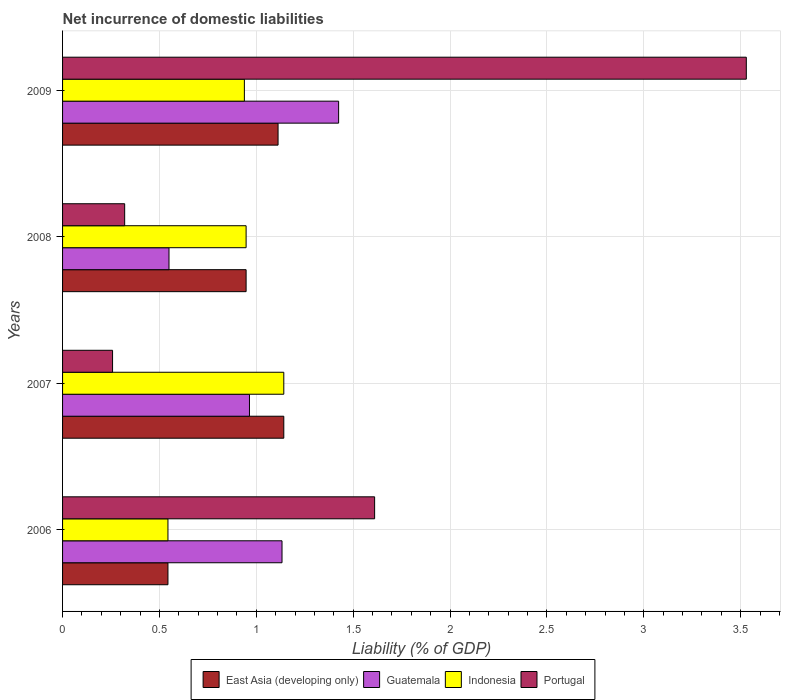Are the number of bars on each tick of the Y-axis equal?
Your answer should be compact. Yes. What is the label of the 1st group of bars from the top?
Your response must be concise. 2009. What is the net incurrence of domestic liabilities in Portugal in 2009?
Offer a very short reply. 3.53. Across all years, what is the maximum net incurrence of domestic liabilities in East Asia (developing only)?
Your answer should be compact. 1.14. Across all years, what is the minimum net incurrence of domestic liabilities in East Asia (developing only)?
Your response must be concise. 0.54. In which year was the net incurrence of domestic liabilities in Portugal minimum?
Give a very brief answer. 2007. What is the total net incurrence of domestic liabilities in Indonesia in the graph?
Make the answer very short. 3.57. What is the difference between the net incurrence of domestic liabilities in Indonesia in 2006 and that in 2008?
Ensure brevity in your answer.  -0.4. What is the difference between the net incurrence of domestic liabilities in Portugal in 2008 and the net incurrence of domestic liabilities in Guatemala in 2007?
Your answer should be very brief. -0.64. What is the average net incurrence of domestic liabilities in Guatemala per year?
Offer a very short reply. 1.02. In the year 2006, what is the difference between the net incurrence of domestic liabilities in East Asia (developing only) and net incurrence of domestic liabilities in Guatemala?
Provide a short and direct response. -0.59. What is the ratio of the net incurrence of domestic liabilities in East Asia (developing only) in 2006 to that in 2008?
Offer a terse response. 0.57. Is the net incurrence of domestic liabilities in Indonesia in 2008 less than that in 2009?
Your response must be concise. No. Is the difference between the net incurrence of domestic liabilities in East Asia (developing only) in 2008 and 2009 greater than the difference between the net incurrence of domestic liabilities in Guatemala in 2008 and 2009?
Offer a terse response. Yes. What is the difference between the highest and the second highest net incurrence of domestic liabilities in Guatemala?
Ensure brevity in your answer.  0.29. What is the difference between the highest and the lowest net incurrence of domestic liabilities in Indonesia?
Keep it short and to the point. 0.6. Is the sum of the net incurrence of domestic liabilities in Portugal in 2008 and 2009 greater than the maximum net incurrence of domestic liabilities in Indonesia across all years?
Give a very brief answer. Yes. What does the 3rd bar from the top in 2006 represents?
Give a very brief answer. Guatemala. What does the 2nd bar from the bottom in 2006 represents?
Provide a short and direct response. Guatemala. Is it the case that in every year, the sum of the net incurrence of domestic liabilities in East Asia (developing only) and net incurrence of domestic liabilities in Guatemala is greater than the net incurrence of domestic liabilities in Indonesia?
Give a very brief answer. Yes. How many bars are there?
Provide a succinct answer. 16. Are the values on the major ticks of X-axis written in scientific E-notation?
Your answer should be very brief. No. Does the graph contain any zero values?
Offer a very short reply. No. How are the legend labels stacked?
Ensure brevity in your answer.  Horizontal. What is the title of the graph?
Make the answer very short. Net incurrence of domestic liabilities. What is the label or title of the X-axis?
Ensure brevity in your answer.  Liability (% of GDP). What is the label or title of the Y-axis?
Make the answer very short. Years. What is the Liability (% of GDP) of East Asia (developing only) in 2006?
Give a very brief answer. 0.54. What is the Liability (% of GDP) in Guatemala in 2006?
Keep it short and to the point. 1.13. What is the Liability (% of GDP) of Indonesia in 2006?
Offer a terse response. 0.54. What is the Liability (% of GDP) in Portugal in 2006?
Give a very brief answer. 1.61. What is the Liability (% of GDP) of East Asia (developing only) in 2007?
Offer a very short reply. 1.14. What is the Liability (% of GDP) in Guatemala in 2007?
Offer a very short reply. 0.96. What is the Liability (% of GDP) in Indonesia in 2007?
Provide a succinct answer. 1.14. What is the Liability (% of GDP) in Portugal in 2007?
Your answer should be compact. 0.26. What is the Liability (% of GDP) in East Asia (developing only) in 2008?
Give a very brief answer. 0.95. What is the Liability (% of GDP) of Guatemala in 2008?
Give a very brief answer. 0.55. What is the Liability (% of GDP) in Indonesia in 2008?
Keep it short and to the point. 0.95. What is the Liability (% of GDP) of Portugal in 2008?
Offer a terse response. 0.32. What is the Liability (% of GDP) of East Asia (developing only) in 2009?
Your answer should be very brief. 1.11. What is the Liability (% of GDP) in Guatemala in 2009?
Your response must be concise. 1.42. What is the Liability (% of GDP) in Indonesia in 2009?
Provide a succinct answer. 0.94. What is the Liability (% of GDP) of Portugal in 2009?
Give a very brief answer. 3.53. Across all years, what is the maximum Liability (% of GDP) in East Asia (developing only)?
Provide a short and direct response. 1.14. Across all years, what is the maximum Liability (% of GDP) of Guatemala?
Your answer should be very brief. 1.42. Across all years, what is the maximum Liability (% of GDP) in Indonesia?
Give a very brief answer. 1.14. Across all years, what is the maximum Liability (% of GDP) of Portugal?
Your answer should be very brief. 3.53. Across all years, what is the minimum Liability (% of GDP) of East Asia (developing only)?
Provide a succinct answer. 0.54. Across all years, what is the minimum Liability (% of GDP) of Guatemala?
Keep it short and to the point. 0.55. Across all years, what is the minimum Liability (% of GDP) of Indonesia?
Make the answer very short. 0.54. Across all years, what is the minimum Liability (% of GDP) of Portugal?
Keep it short and to the point. 0.26. What is the total Liability (% of GDP) of East Asia (developing only) in the graph?
Offer a terse response. 3.75. What is the total Liability (% of GDP) of Guatemala in the graph?
Make the answer very short. 4.07. What is the total Liability (% of GDP) in Indonesia in the graph?
Offer a terse response. 3.57. What is the total Liability (% of GDP) in Portugal in the graph?
Give a very brief answer. 5.72. What is the difference between the Liability (% of GDP) in East Asia (developing only) in 2006 and that in 2007?
Your response must be concise. -0.6. What is the difference between the Liability (% of GDP) of Guatemala in 2006 and that in 2007?
Give a very brief answer. 0.17. What is the difference between the Liability (% of GDP) of Indonesia in 2006 and that in 2007?
Your answer should be very brief. -0.6. What is the difference between the Liability (% of GDP) in Portugal in 2006 and that in 2007?
Ensure brevity in your answer.  1.35. What is the difference between the Liability (% of GDP) in East Asia (developing only) in 2006 and that in 2008?
Provide a short and direct response. -0.4. What is the difference between the Liability (% of GDP) of Guatemala in 2006 and that in 2008?
Make the answer very short. 0.58. What is the difference between the Liability (% of GDP) in Indonesia in 2006 and that in 2008?
Provide a succinct answer. -0.4. What is the difference between the Liability (% of GDP) of Portugal in 2006 and that in 2008?
Make the answer very short. 1.29. What is the difference between the Liability (% of GDP) of East Asia (developing only) in 2006 and that in 2009?
Offer a very short reply. -0.57. What is the difference between the Liability (% of GDP) in Guatemala in 2006 and that in 2009?
Make the answer very short. -0.29. What is the difference between the Liability (% of GDP) in Indonesia in 2006 and that in 2009?
Your response must be concise. -0.39. What is the difference between the Liability (% of GDP) in Portugal in 2006 and that in 2009?
Offer a terse response. -1.92. What is the difference between the Liability (% of GDP) in East Asia (developing only) in 2007 and that in 2008?
Offer a very short reply. 0.19. What is the difference between the Liability (% of GDP) of Guatemala in 2007 and that in 2008?
Offer a very short reply. 0.42. What is the difference between the Liability (% of GDP) in Indonesia in 2007 and that in 2008?
Your answer should be compact. 0.19. What is the difference between the Liability (% of GDP) in Portugal in 2007 and that in 2008?
Your answer should be very brief. -0.06. What is the difference between the Liability (% of GDP) of East Asia (developing only) in 2007 and that in 2009?
Ensure brevity in your answer.  0.03. What is the difference between the Liability (% of GDP) of Guatemala in 2007 and that in 2009?
Provide a succinct answer. -0.46. What is the difference between the Liability (% of GDP) in Indonesia in 2007 and that in 2009?
Your answer should be compact. 0.2. What is the difference between the Liability (% of GDP) in Portugal in 2007 and that in 2009?
Your response must be concise. -3.27. What is the difference between the Liability (% of GDP) of East Asia (developing only) in 2008 and that in 2009?
Provide a short and direct response. -0.16. What is the difference between the Liability (% of GDP) in Guatemala in 2008 and that in 2009?
Give a very brief answer. -0.88. What is the difference between the Liability (% of GDP) of Indonesia in 2008 and that in 2009?
Offer a terse response. 0.01. What is the difference between the Liability (% of GDP) in Portugal in 2008 and that in 2009?
Make the answer very short. -3.21. What is the difference between the Liability (% of GDP) in East Asia (developing only) in 2006 and the Liability (% of GDP) in Guatemala in 2007?
Offer a very short reply. -0.42. What is the difference between the Liability (% of GDP) of East Asia (developing only) in 2006 and the Liability (% of GDP) of Indonesia in 2007?
Your answer should be compact. -0.6. What is the difference between the Liability (% of GDP) in East Asia (developing only) in 2006 and the Liability (% of GDP) in Portugal in 2007?
Provide a short and direct response. 0.29. What is the difference between the Liability (% of GDP) in Guatemala in 2006 and the Liability (% of GDP) in Indonesia in 2007?
Offer a very short reply. -0.01. What is the difference between the Liability (% of GDP) in Guatemala in 2006 and the Liability (% of GDP) in Portugal in 2007?
Make the answer very short. 0.87. What is the difference between the Liability (% of GDP) in Indonesia in 2006 and the Liability (% of GDP) in Portugal in 2007?
Your response must be concise. 0.29. What is the difference between the Liability (% of GDP) in East Asia (developing only) in 2006 and the Liability (% of GDP) in Guatemala in 2008?
Provide a short and direct response. -0.01. What is the difference between the Liability (% of GDP) of East Asia (developing only) in 2006 and the Liability (% of GDP) of Indonesia in 2008?
Your answer should be compact. -0.4. What is the difference between the Liability (% of GDP) of East Asia (developing only) in 2006 and the Liability (% of GDP) of Portugal in 2008?
Offer a terse response. 0.22. What is the difference between the Liability (% of GDP) of Guatemala in 2006 and the Liability (% of GDP) of Indonesia in 2008?
Your answer should be very brief. 0.19. What is the difference between the Liability (% of GDP) of Guatemala in 2006 and the Liability (% of GDP) of Portugal in 2008?
Your answer should be very brief. 0.81. What is the difference between the Liability (% of GDP) of Indonesia in 2006 and the Liability (% of GDP) of Portugal in 2008?
Keep it short and to the point. 0.22. What is the difference between the Liability (% of GDP) in East Asia (developing only) in 2006 and the Liability (% of GDP) in Guatemala in 2009?
Provide a short and direct response. -0.88. What is the difference between the Liability (% of GDP) in East Asia (developing only) in 2006 and the Liability (% of GDP) in Indonesia in 2009?
Ensure brevity in your answer.  -0.39. What is the difference between the Liability (% of GDP) in East Asia (developing only) in 2006 and the Liability (% of GDP) in Portugal in 2009?
Offer a very short reply. -2.99. What is the difference between the Liability (% of GDP) in Guatemala in 2006 and the Liability (% of GDP) in Indonesia in 2009?
Provide a succinct answer. 0.19. What is the difference between the Liability (% of GDP) of Guatemala in 2006 and the Liability (% of GDP) of Portugal in 2009?
Give a very brief answer. -2.4. What is the difference between the Liability (% of GDP) of Indonesia in 2006 and the Liability (% of GDP) of Portugal in 2009?
Provide a short and direct response. -2.99. What is the difference between the Liability (% of GDP) of East Asia (developing only) in 2007 and the Liability (% of GDP) of Guatemala in 2008?
Keep it short and to the point. 0.59. What is the difference between the Liability (% of GDP) of East Asia (developing only) in 2007 and the Liability (% of GDP) of Indonesia in 2008?
Offer a very short reply. 0.19. What is the difference between the Liability (% of GDP) of East Asia (developing only) in 2007 and the Liability (% of GDP) of Portugal in 2008?
Offer a very short reply. 0.82. What is the difference between the Liability (% of GDP) of Guatemala in 2007 and the Liability (% of GDP) of Indonesia in 2008?
Your answer should be compact. 0.02. What is the difference between the Liability (% of GDP) in Guatemala in 2007 and the Liability (% of GDP) in Portugal in 2008?
Give a very brief answer. 0.64. What is the difference between the Liability (% of GDP) in Indonesia in 2007 and the Liability (% of GDP) in Portugal in 2008?
Your answer should be very brief. 0.82. What is the difference between the Liability (% of GDP) in East Asia (developing only) in 2007 and the Liability (% of GDP) in Guatemala in 2009?
Your answer should be very brief. -0.28. What is the difference between the Liability (% of GDP) in East Asia (developing only) in 2007 and the Liability (% of GDP) in Indonesia in 2009?
Provide a short and direct response. 0.2. What is the difference between the Liability (% of GDP) of East Asia (developing only) in 2007 and the Liability (% of GDP) of Portugal in 2009?
Offer a very short reply. -2.39. What is the difference between the Liability (% of GDP) of Guatemala in 2007 and the Liability (% of GDP) of Indonesia in 2009?
Provide a short and direct response. 0.03. What is the difference between the Liability (% of GDP) in Guatemala in 2007 and the Liability (% of GDP) in Portugal in 2009?
Your answer should be very brief. -2.56. What is the difference between the Liability (% of GDP) in Indonesia in 2007 and the Liability (% of GDP) in Portugal in 2009?
Offer a terse response. -2.39. What is the difference between the Liability (% of GDP) of East Asia (developing only) in 2008 and the Liability (% of GDP) of Guatemala in 2009?
Ensure brevity in your answer.  -0.48. What is the difference between the Liability (% of GDP) in East Asia (developing only) in 2008 and the Liability (% of GDP) in Indonesia in 2009?
Provide a short and direct response. 0.01. What is the difference between the Liability (% of GDP) in East Asia (developing only) in 2008 and the Liability (% of GDP) in Portugal in 2009?
Make the answer very short. -2.58. What is the difference between the Liability (% of GDP) of Guatemala in 2008 and the Liability (% of GDP) of Indonesia in 2009?
Provide a short and direct response. -0.39. What is the difference between the Liability (% of GDP) in Guatemala in 2008 and the Liability (% of GDP) in Portugal in 2009?
Your response must be concise. -2.98. What is the difference between the Liability (% of GDP) in Indonesia in 2008 and the Liability (% of GDP) in Portugal in 2009?
Your answer should be very brief. -2.58. What is the average Liability (% of GDP) of East Asia (developing only) per year?
Your response must be concise. 0.94. What is the average Liability (% of GDP) of Guatemala per year?
Provide a short and direct response. 1.02. What is the average Liability (% of GDP) in Indonesia per year?
Provide a succinct answer. 0.89. What is the average Liability (% of GDP) of Portugal per year?
Make the answer very short. 1.43. In the year 2006, what is the difference between the Liability (% of GDP) in East Asia (developing only) and Liability (% of GDP) in Guatemala?
Your answer should be compact. -0.59. In the year 2006, what is the difference between the Liability (% of GDP) in East Asia (developing only) and Liability (% of GDP) in Portugal?
Your response must be concise. -1.07. In the year 2006, what is the difference between the Liability (% of GDP) of Guatemala and Liability (% of GDP) of Indonesia?
Your answer should be compact. 0.59. In the year 2006, what is the difference between the Liability (% of GDP) in Guatemala and Liability (% of GDP) in Portugal?
Provide a short and direct response. -0.48. In the year 2006, what is the difference between the Liability (% of GDP) of Indonesia and Liability (% of GDP) of Portugal?
Your answer should be compact. -1.07. In the year 2007, what is the difference between the Liability (% of GDP) of East Asia (developing only) and Liability (% of GDP) of Guatemala?
Offer a very short reply. 0.18. In the year 2007, what is the difference between the Liability (% of GDP) in East Asia (developing only) and Liability (% of GDP) in Portugal?
Your answer should be compact. 0.88. In the year 2007, what is the difference between the Liability (% of GDP) in Guatemala and Liability (% of GDP) in Indonesia?
Make the answer very short. -0.18. In the year 2007, what is the difference between the Liability (% of GDP) of Guatemala and Liability (% of GDP) of Portugal?
Give a very brief answer. 0.71. In the year 2007, what is the difference between the Liability (% of GDP) of Indonesia and Liability (% of GDP) of Portugal?
Offer a very short reply. 0.88. In the year 2008, what is the difference between the Liability (% of GDP) of East Asia (developing only) and Liability (% of GDP) of Guatemala?
Offer a terse response. 0.4. In the year 2008, what is the difference between the Liability (% of GDP) in East Asia (developing only) and Liability (% of GDP) in Indonesia?
Your answer should be very brief. 0. In the year 2008, what is the difference between the Liability (% of GDP) of East Asia (developing only) and Liability (% of GDP) of Portugal?
Your answer should be very brief. 0.63. In the year 2008, what is the difference between the Liability (% of GDP) of Guatemala and Liability (% of GDP) of Indonesia?
Offer a very short reply. -0.4. In the year 2008, what is the difference between the Liability (% of GDP) of Guatemala and Liability (% of GDP) of Portugal?
Provide a succinct answer. 0.23. In the year 2008, what is the difference between the Liability (% of GDP) in Indonesia and Liability (% of GDP) in Portugal?
Offer a very short reply. 0.63. In the year 2009, what is the difference between the Liability (% of GDP) in East Asia (developing only) and Liability (% of GDP) in Guatemala?
Ensure brevity in your answer.  -0.31. In the year 2009, what is the difference between the Liability (% of GDP) of East Asia (developing only) and Liability (% of GDP) of Indonesia?
Provide a succinct answer. 0.17. In the year 2009, what is the difference between the Liability (% of GDP) of East Asia (developing only) and Liability (% of GDP) of Portugal?
Keep it short and to the point. -2.42. In the year 2009, what is the difference between the Liability (% of GDP) of Guatemala and Liability (% of GDP) of Indonesia?
Offer a terse response. 0.49. In the year 2009, what is the difference between the Liability (% of GDP) in Guatemala and Liability (% of GDP) in Portugal?
Ensure brevity in your answer.  -2.1. In the year 2009, what is the difference between the Liability (% of GDP) in Indonesia and Liability (% of GDP) in Portugal?
Provide a short and direct response. -2.59. What is the ratio of the Liability (% of GDP) in East Asia (developing only) in 2006 to that in 2007?
Your answer should be very brief. 0.48. What is the ratio of the Liability (% of GDP) in Guatemala in 2006 to that in 2007?
Make the answer very short. 1.17. What is the ratio of the Liability (% of GDP) in Indonesia in 2006 to that in 2007?
Provide a short and direct response. 0.48. What is the ratio of the Liability (% of GDP) of Portugal in 2006 to that in 2007?
Give a very brief answer. 6.24. What is the ratio of the Liability (% of GDP) of East Asia (developing only) in 2006 to that in 2008?
Your answer should be very brief. 0.57. What is the ratio of the Liability (% of GDP) of Guatemala in 2006 to that in 2008?
Keep it short and to the point. 2.06. What is the ratio of the Liability (% of GDP) in Indonesia in 2006 to that in 2008?
Your response must be concise. 0.57. What is the ratio of the Liability (% of GDP) in Portugal in 2006 to that in 2008?
Keep it short and to the point. 5.02. What is the ratio of the Liability (% of GDP) in East Asia (developing only) in 2006 to that in 2009?
Keep it short and to the point. 0.49. What is the ratio of the Liability (% of GDP) in Guatemala in 2006 to that in 2009?
Provide a short and direct response. 0.8. What is the ratio of the Liability (% of GDP) in Indonesia in 2006 to that in 2009?
Ensure brevity in your answer.  0.58. What is the ratio of the Liability (% of GDP) in Portugal in 2006 to that in 2009?
Make the answer very short. 0.46. What is the ratio of the Liability (% of GDP) of East Asia (developing only) in 2007 to that in 2008?
Your response must be concise. 1.21. What is the ratio of the Liability (% of GDP) in Guatemala in 2007 to that in 2008?
Your answer should be very brief. 1.76. What is the ratio of the Liability (% of GDP) of Indonesia in 2007 to that in 2008?
Make the answer very short. 1.21. What is the ratio of the Liability (% of GDP) in Portugal in 2007 to that in 2008?
Ensure brevity in your answer.  0.81. What is the ratio of the Liability (% of GDP) in East Asia (developing only) in 2007 to that in 2009?
Provide a succinct answer. 1.03. What is the ratio of the Liability (% of GDP) of Guatemala in 2007 to that in 2009?
Ensure brevity in your answer.  0.68. What is the ratio of the Liability (% of GDP) of Indonesia in 2007 to that in 2009?
Provide a succinct answer. 1.22. What is the ratio of the Liability (% of GDP) in Portugal in 2007 to that in 2009?
Give a very brief answer. 0.07. What is the ratio of the Liability (% of GDP) of East Asia (developing only) in 2008 to that in 2009?
Your response must be concise. 0.85. What is the ratio of the Liability (% of GDP) in Guatemala in 2008 to that in 2009?
Your response must be concise. 0.39. What is the ratio of the Liability (% of GDP) in Indonesia in 2008 to that in 2009?
Offer a very short reply. 1.01. What is the ratio of the Liability (% of GDP) in Portugal in 2008 to that in 2009?
Your answer should be very brief. 0.09. What is the difference between the highest and the second highest Liability (% of GDP) of East Asia (developing only)?
Ensure brevity in your answer.  0.03. What is the difference between the highest and the second highest Liability (% of GDP) in Guatemala?
Your response must be concise. 0.29. What is the difference between the highest and the second highest Liability (% of GDP) of Indonesia?
Give a very brief answer. 0.19. What is the difference between the highest and the second highest Liability (% of GDP) of Portugal?
Provide a short and direct response. 1.92. What is the difference between the highest and the lowest Liability (% of GDP) of East Asia (developing only)?
Provide a succinct answer. 0.6. What is the difference between the highest and the lowest Liability (% of GDP) in Guatemala?
Your answer should be compact. 0.88. What is the difference between the highest and the lowest Liability (% of GDP) of Indonesia?
Give a very brief answer. 0.6. What is the difference between the highest and the lowest Liability (% of GDP) in Portugal?
Provide a succinct answer. 3.27. 